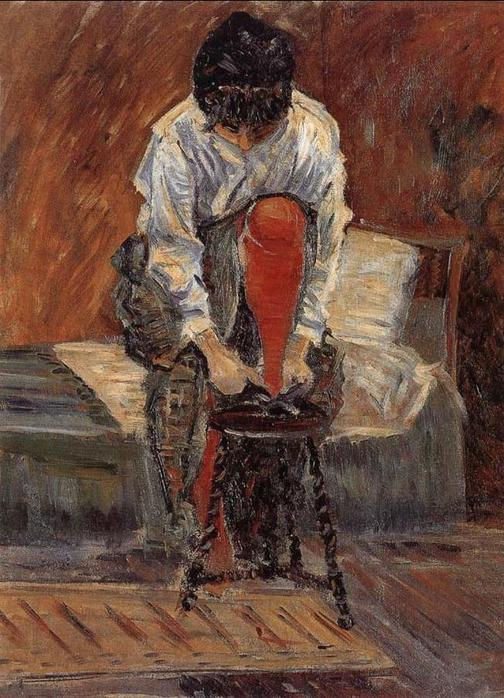What might the woman in the painting be thinking about? The woman in the painting might be lost in her thoughts about personal matters or perhaps reflecting on a piece of literature she is reading. The solemn ambiance and her focused posture suggest deep contemplation, possibly concerning events in her life or planning for the future. 